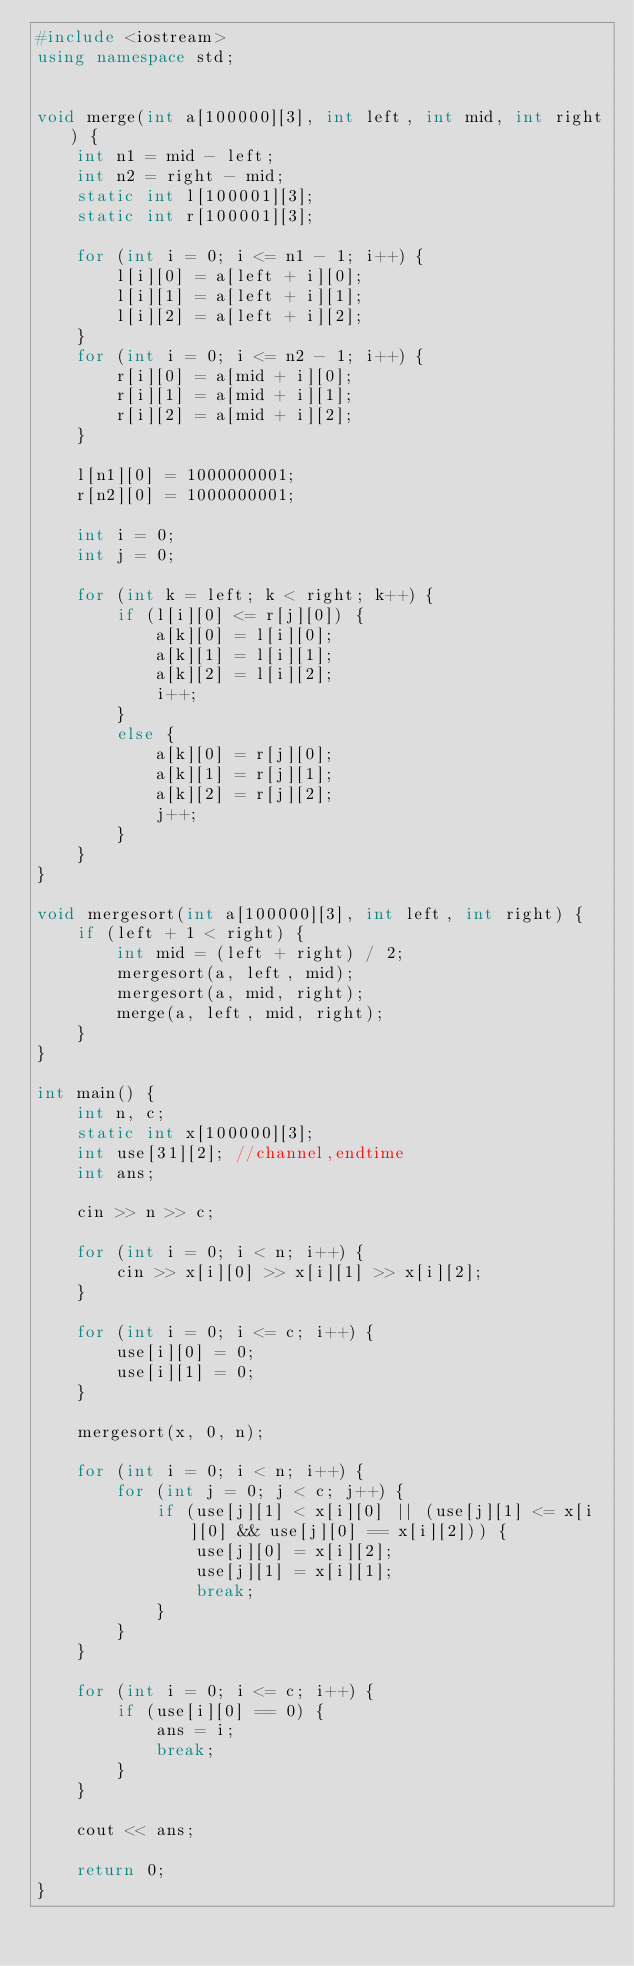Convert code to text. <code><loc_0><loc_0><loc_500><loc_500><_C++_>#include <iostream>
using namespace std;


void merge(int a[100000][3], int left, int mid, int right) {
	int n1 = mid - left;
	int n2 = right - mid;
	static int l[100001][3];
	static int r[100001][3];

	for (int i = 0; i <= n1 - 1; i++) {
		l[i][0] = a[left + i][0];
		l[i][1] = a[left + i][1];
		l[i][2] = a[left + i][2];
	}
	for (int i = 0; i <= n2 - 1; i++) {
		r[i][0] = a[mid + i][0];
		r[i][1] = a[mid + i][1];
		r[i][2] = a[mid + i][2];
	}

	l[n1][0] = 1000000001;
	r[n2][0] = 1000000001;

	int i = 0;
	int j = 0;

	for (int k = left; k < right; k++) {
		if (l[i][0] <= r[j][0]) {
			a[k][0] = l[i][0];
			a[k][1] = l[i][1];
			a[k][2] = l[i][2];
			i++;
		}
		else {
			a[k][0] = r[j][0];
			a[k][1] = r[j][1];
			a[k][2] = r[j][2];
			j++;
		}
	}
}

void mergesort(int a[100000][3], int left, int right) {
	if (left + 1 < right) {
		int mid = (left + right) / 2;
		mergesort(a, left, mid);
		mergesort(a, mid, right);
		merge(a, left, mid, right);
	}
}

int main() {
	int n, c;
	static int x[100000][3];
	int use[31][2]; //channel,endtime
	int ans;

	cin >> n >> c;

	for (int i = 0; i < n; i++) {
		cin >> x[i][0] >> x[i][1] >> x[i][2];
	}

	for (int i = 0; i <= c; i++) {
		use[i][0] = 0;
		use[i][1] = 0;
	}

	mergesort(x, 0, n);

	for (int i = 0; i < n; i++) {
		for (int j = 0; j < c; j++) {
			if (use[j][1] < x[i][0] || (use[j][1] <= x[i][0] && use[j][0] == x[i][2])) {
				use[j][0] = x[i][2];
				use[j][1] = x[i][1];
				break;
			}
		}
	}

	for (int i = 0; i <= c; i++) {
		if (use[i][0] == 0) {
			ans = i;
			break;
		}
	}

	cout << ans;

	return 0;
}</code> 